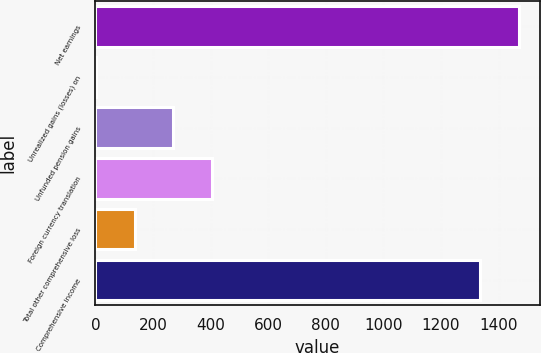<chart> <loc_0><loc_0><loc_500><loc_500><bar_chart><fcel>Net earnings<fcel>Unrealized gains (losses) on<fcel>Unfunded pension gains<fcel>Foreign currency translation<fcel>Total other comprehensive loss<fcel>Comprehensive income<nl><fcel>1469.3<fcel>2<fcel>270.6<fcel>404.9<fcel>136.3<fcel>1335<nl></chart> 